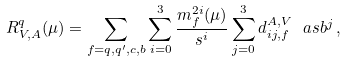Convert formula to latex. <formula><loc_0><loc_0><loc_500><loc_500>R _ { V , A } ^ { q } ( \mu ) = \sum _ { f = q , q ^ { \prime } , c , b } \sum _ { i = 0 } ^ { 3 } \frac { m _ { f } ^ { 2 i } ( \mu ) } { s ^ { i } } \sum _ { j = 0 } ^ { 3 } d _ { i j , f } ^ { A , V } \ a s b ^ { j } \, ,</formula> 